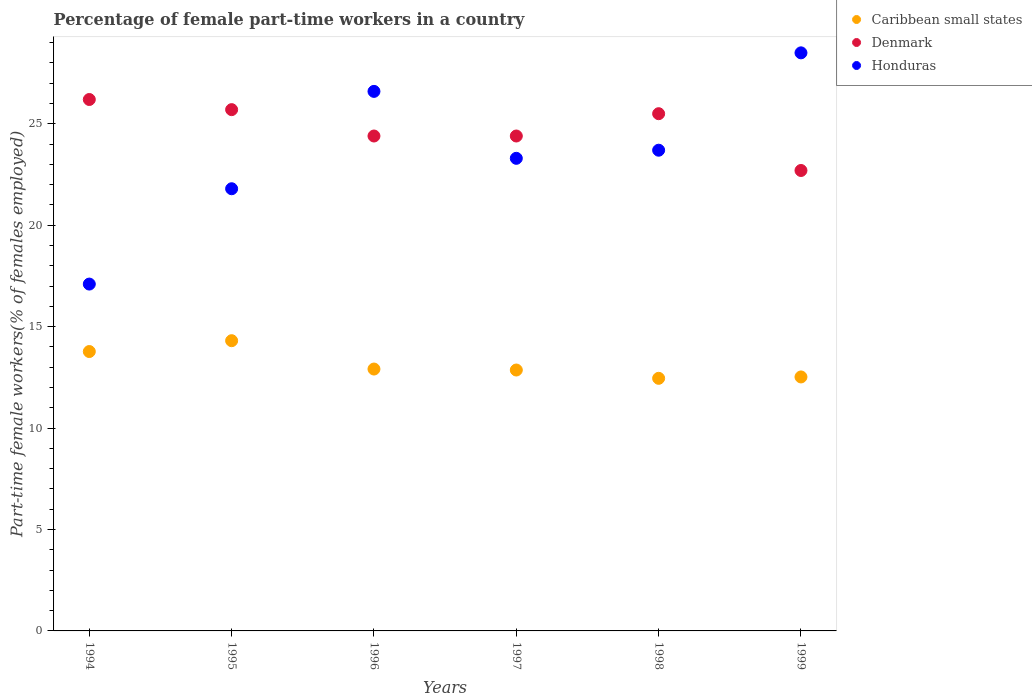Is the number of dotlines equal to the number of legend labels?
Your answer should be compact. Yes. What is the percentage of female part-time workers in Caribbean small states in 1995?
Provide a succinct answer. 14.31. Across all years, what is the maximum percentage of female part-time workers in Denmark?
Ensure brevity in your answer.  26.2. Across all years, what is the minimum percentage of female part-time workers in Caribbean small states?
Your answer should be compact. 12.45. In which year was the percentage of female part-time workers in Honduras maximum?
Your answer should be very brief. 1999. In which year was the percentage of female part-time workers in Honduras minimum?
Your response must be concise. 1994. What is the total percentage of female part-time workers in Denmark in the graph?
Your answer should be very brief. 148.9. What is the difference between the percentage of female part-time workers in Honduras in 1996 and that in 1999?
Provide a short and direct response. -1.9. What is the difference between the percentage of female part-time workers in Denmark in 1997 and the percentage of female part-time workers in Caribbean small states in 1999?
Provide a short and direct response. 11.88. What is the average percentage of female part-time workers in Honduras per year?
Provide a short and direct response. 23.5. In the year 1996, what is the difference between the percentage of female part-time workers in Caribbean small states and percentage of female part-time workers in Denmark?
Provide a succinct answer. -11.49. What is the ratio of the percentage of female part-time workers in Honduras in 1996 to that in 1998?
Keep it short and to the point. 1.12. Is the sum of the percentage of female part-time workers in Honduras in 1995 and 1999 greater than the maximum percentage of female part-time workers in Caribbean small states across all years?
Offer a very short reply. Yes. Is the percentage of female part-time workers in Denmark strictly greater than the percentage of female part-time workers in Honduras over the years?
Offer a very short reply. No. How many dotlines are there?
Your answer should be very brief. 3. How many years are there in the graph?
Offer a very short reply. 6. Are the values on the major ticks of Y-axis written in scientific E-notation?
Provide a short and direct response. No. Does the graph contain grids?
Your answer should be very brief. No. Where does the legend appear in the graph?
Your response must be concise. Top right. How many legend labels are there?
Keep it short and to the point. 3. How are the legend labels stacked?
Make the answer very short. Vertical. What is the title of the graph?
Offer a terse response. Percentage of female part-time workers in a country. What is the label or title of the Y-axis?
Your response must be concise. Part-time female workers(% of females employed). What is the Part-time female workers(% of females employed) of Caribbean small states in 1994?
Provide a succinct answer. 13.77. What is the Part-time female workers(% of females employed) in Denmark in 1994?
Make the answer very short. 26.2. What is the Part-time female workers(% of females employed) in Honduras in 1994?
Make the answer very short. 17.1. What is the Part-time female workers(% of females employed) of Caribbean small states in 1995?
Give a very brief answer. 14.31. What is the Part-time female workers(% of females employed) of Denmark in 1995?
Ensure brevity in your answer.  25.7. What is the Part-time female workers(% of females employed) of Honduras in 1995?
Provide a succinct answer. 21.8. What is the Part-time female workers(% of females employed) in Caribbean small states in 1996?
Offer a very short reply. 12.91. What is the Part-time female workers(% of females employed) in Denmark in 1996?
Your response must be concise. 24.4. What is the Part-time female workers(% of females employed) of Honduras in 1996?
Provide a short and direct response. 26.6. What is the Part-time female workers(% of females employed) in Caribbean small states in 1997?
Your answer should be very brief. 12.86. What is the Part-time female workers(% of females employed) in Denmark in 1997?
Your answer should be compact. 24.4. What is the Part-time female workers(% of females employed) of Honduras in 1997?
Provide a succinct answer. 23.3. What is the Part-time female workers(% of females employed) of Caribbean small states in 1998?
Give a very brief answer. 12.45. What is the Part-time female workers(% of females employed) in Denmark in 1998?
Your answer should be very brief. 25.5. What is the Part-time female workers(% of females employed) of Honduras in 1998?
Give a very brief answer. 23.7. What is the Part-time female workers(% of females employed) of Caribbean small states in 1999?
Keep it short and to the point. 12.52. What is the Part-time female workers(% of females employed) in Denmark in 1999?
Give a very brief answer. 22.7. What is the Part-time female workers(% of females employed) in Honduras in 1999?
Make the answer very short. 28.5. Across all years, what is the maximum Part-time female workers(% of females employed) of Caribbean small states?
Your response must be concise. 14.31. Across all years, what is the maximum Part-time female workers(% of females employed) of Denmark?
Provide a short and direct response. 26.2. Across all years, what is the maximum Part-time female workers(% of females employed) in Honduras?
Your response must be concise. 28.5. Across all years, what is the minimum Part-time female workers(% of females employed) of Caribbean small states?
Keep it short and to the point. 12.45. Across all years, what is the minimum Part-time female workers(% of females employed) in Denmark?
Provide a succinct answer. 22.7. Across all years, what is the minimum Part-time female workers(% of females employed) of Honduras?
Provide a short and direct response. 17.1. What is the total Part-time female workers(% of females employed) in Caribbean small states in the graph?
Keep it short and to the point. 78.83. What is the total Part-time female workers(% of females employed) in Denmark in the graph?
Make the answer very short. 148.9. What is the total Part-time female workers(% of females employed) of Honduras in the graph?
Offer a terse response. 141. What is the difference between the Part-time female workers(% of females employed) in Caribbean small states in 1994 and that in 1995?
Make the answer very short. -0.53. What is the difference between the Part-time female workers(% of females employed) in Denmark in 1994 and that in 1995?
Your response must be concise. 0.5. What is the difference between the Part-time female workers(% of females employed) in Honduras in 1994 and that in 1995?
Keep it short and to the point. -4.7. What is the difference between the Part-time female workers(% of females employed) in Caribbean small states in 1994 and that in 1996?
Your answer should be compact. 0.86. What is the difference between the Part-time female workers(% of females employed) of Denmark in 1994 and that in 1996?
Ensure brevity in your answer.  1.8. What is the difference between the Part-time female workers(% of females employed) in Honduras in 1994 and that in 1996?
Your answer should be very brief. -9.5. What is the difference between the Part-time female workers(% of females employed) of Caribbean small states in 1994 and that in 1997?
Your answer should be compact. 0.91. What is the difference between the Part-time female workers(% of females employed) of Caribbean small states in 1994 and that in 1998?
Make the answer very short. 1.32. What is the difference between the Part-time female workers(% of females employed) in Honduras in 1994 and that in 1998?
Provide a succinct answer. -6.6. What is the difference between the Part-time female workers(% of females employed) of Caribbean small states in 1994 and that in 1999?
Your response must be concise. 1.25. What is the difference between the Part-time female workers(% of females employed) in Caribbean small states in 1995 and that in 1996?
Make the answer very short. 1.4. What is the difference between the Part-time female workers(% of females employed) of Honduras in 1995 and that in 1996?
Provide a succinct answer. -4.8. What is the difference between the Part-time female workers(% of females employed) of Caribbean small states in 1995 and that in 1997?
Offer a very short reply. 1.45. What is the difference between the Part-time female workers(% of females employed) of Caribbean small states in 1995 and that in 1998?
Provide a succinct answer. 1.85. What is the difference between the Part-time female workers(% of females employed) in Honduras in 1995 and that in 1998?
Provide a short and direct response. -1.9. What is the difference between the Part-time female workers(% of females employed) in Caribbean small states in 1995 and that in 1999?
Ensure brevity in your answer.  1.79. What is the difference between the Part-time female workers(% of females employed) in Denmark in 1995 and that in 1999?
Give a very brief answer. 3. What is the difference between the Part-time female workers(% of females employed) of Honduras in 1995 and that in 1999?
Your response must be concise. -6.7. What is the difference between the Part-time female workers(% of females employed) in Caribbean small states in 1996 and that in 1997?
Make the answer very short. 0.05. What is the difference between the Part-time female workers(% of females employed) of Denmark in 1996 and that in 1997?
Ensure brevity in your answer.  0. What is the difference between the Part-time female workers(% of females employed) in Honduras in 1996 and that in 1997?
Keep it short and to the point. 3.3. What is the difference between the Part-time female workers(% of females employed) in Caribbean small states in 1996 and that in 1998?
Your response must be concise. 0.46. What is the difference between the Part-time female workers(% of females employed) in Caribbean small states in 1996 and that in 1999?
Keep it short and to the point. 0.39. What is the difference between the Part-time female workers(% of females employed) of Denmark in 1996 and that in 1999?
Provide a succinct answer. 1.7. What is the difference between the Part-time female workers(% of females employed) of Caribbean small states in 1997 and that in 1998?
Offer a very short reply. 0.41. What is the difference between the Part-time female workers(% of females employed) in Denmark in 1997 and that in 1998?
Give a very brief answer. -1.1. What is the difference between the Part-time female workers(% of females employed) of Honduras in 1997 and that in 1998?
Your response must be concise. -0.4. What is the difference between the Part-time female workers(% of females employed) of Caribbean small states in 1997 and that in 1999?
Your response must be concise. 0.34. What is the difference between the Part-time female workers(% of females employed) in Caribbean small states in 1998 and that in 1999?
Ensure brevity in your answer.  -0.07. What is the difference between the Part-time female workers(% of females employed) in Denmark in 1998 and that in 1999?
Provide a short and direct response. 2.8. What is the difference between the Part-time female workers(% of females employed) in Honduras in 1998 and that in 1999?
Make the answer very short. -4.8. What is the difference between the Part-time female workers(% of females employed) in Caribbean small states in 1994 and the Part-time female workers(% of females employed) in Denmark in 1995?
Ensure brevity in your answer.  -11.93. What is the difference between the Part-time female workers(% of females employed) of Caribbean small states in 1994 and the Part-time female workers(% of females employed) of Honduras in 1995?
Offer a very short reply. -8.03. What is the difference between the Part-time female workers(% of females employed) of Caribbean small states in 1994 and the Part-time female workers(% of females employed) of Denmark in 1996?
Make the answer very short. -10.63. What is the difference between the Part-time female workers(% of females employed) in Caribbean small states in 1994 and the Part-time female workers(% of females employed) in Honduras in 1996?
Provide a succinct answer. -12.83. What is the difference between the Part-time female workers(% of females employed) of Caribbean small states in 1994 and the Part-time female workers(% of females employed) of Denmark in 1997?
Ensure brevity in your answer.  -10.63. What is the difference between the Part-time female workers(% of females employed) in Caribbean small states in 1994 and the Part-time female workers(% of females employed) in Honduras in 1997?
Provide a succinct answer. -9.53. What is the difference between the Part-time female workers(% of females employed) of Denmark in 1994 and the Part-time female workers(% of females employed) of Honduras in 1997?
Your response must be concise. 2.9. What is the difference between the Part-time female workers(% of females employed) of Caribbean small states in 1994 and the Part-time female workers(% of females employed) of Denmark in 1998?
Provide a succinct answer. -11.73. What is the difference between the Part-time female workers(% of females employed) of Caribbean small states in 1994 and the Part-time female workers(% of females employed) of Honduras in 1998?
Your answer should be very brief. -9.93. What is the difference between the Part-time female workers(% of females employed) of Caribbean small states in 1994 and the Part-time female workers(% of females employed) of Denmark in 1999?
Keep it short and to the point. -8.93. What is the difference between the Part-time female workers(% of females employed) of Caribbean small states in 1994 and the Part-time female workers(% of females employed) of Honduras in 1999?
Give a very brief answer. -14.73. What is the difference between the Part-time female workers(% of females employed) of Denmark in 1994 and the Part-time female workers(% of females employed) of Honduras in 1999?
Provide a short and direct response. -2.3. What is the difference between the Part-time female workers(% of females employed) of Caribbean small states in 1995 and the Part-time female workers(% of females employed) of Denmark in 1996?
Your response must be concise. -10.09. What is the difference between the Part-time female workers(% of females employed) of Caribbean small states in 1995 and the Part-time female workers(% of females employed) of Honduras in 1996?
Make the answer very short. -12.29. What is the difference between the Part-time female workers(% of females employed) of Caribbean small states in 1995 and the Part-time female workers(% of females employed) of Denmark in 1997?
Keep it short and to the point. -10.09. What is the difference between the Part-time female workers(% of females employed) of Caribbean small states in 1995 and the Part-time female workers(% of females employed) of Honduras in 1997?
Ensure brevity in your answer.  -8.99. What is the difference between the Part-time female workers(% of females employed) in Denmark in 1995 and the Part-time female workers(% of females employed) in Honduras in 1997?
Keep it short and to the point. 2.4. What is the difference between the Part-time female workers(% of females employed) in Caribbean small states in 1995 and the Part-time female workers(% of females employed) in Denmark in 1998?
Provide a short and direct response. -11.19. What is the difference between the Part-time female workers(% of females employed) of Caribbean small states in 1995 and the Part-time female workers(% of females employed) of Honduras in 1998?
Your answer should be compact. -9.39. What is the difference between the Part-time female workers(% of females employed) of Denmark in 1995 and the Part-time female workers(% of females employed) of Honduras in 1998?
Your answer should be compact. 2. What is the difference between the Part-time female workers(% of females employed) in Caribbean small states in 1995 and the Part-time female workers(% of females employed) in Denmark in 1999?
Make the answer very short. -8.39. What is the difference between the Part-time female workers(% of females employed) in Caribbean small states in 1995 and the Part-time female workers(% of females employed) in Honduras in 1999?
Give a very brief answer. -14.19. What is the difference between the Part-time female workers(% of females employed) of Caribbean small states in 1996 and the Part-time female workers(% of females employed) of Denmark in 1997?
Make the answer very short. -11.49. What is the difference between the Part-time female workers(% of females employed) in Caribbean small states in 1996 and the Part-time female workers(% of females employed) in Honduras in 1997?
Offer a terse response. -10.39. What is the difference between the Part-time female workers(% of females employed) of Caribbean small states in 1996 and the Part-time female workers(% of females employed) of Denmark in 1998?
Offer a terse response. -12.59. What is the difference between the Part-time female workers(% of females employed) of Caribbean small states in 1996 and the Part-time female workers(% of females employed) of Honduras in 1998?
Keep it short and to the point. -10.79. What is the difference between the Part-time female workers(% of females employed) of Caribbean small states in 1996 and the Part-time female workers(% of females employed) of Denmark in 1999?
Your answer should be very brief. -9.79. What is the difference between the Part-time female workers(% of females employed) in Caribbean small states in 1996 and the Part-time female workers(% of females employed) in Honduras in 1999?
Give a very brief answer. -15.59. What is the difference between the Part-time female workers(% of females employed) in Denmark in 1996 and the Part-time female workers(% of females employed) in Honduras in 1999?
Your answer should be very brief. -4.1. What is the difference between the Part-time female workers(% of females employed) in Caribbean small states in 1997 and the Part-time female workers(% of females employed) in Denmark in 1998?
Offer a very short reply. -12.64. What is the difference between the Part-time female workers(% of females employed) of Caribbean small states in 1997 and the Part-time female workers(% of females employed) of Honduras in 1998?
Keep it short and to the point. -10.84. What is the difference between the Part-time female workers(% of females employed) in Denmark in 1997 and the Part-time female workers(% of females employed) in Honduras in 1998?
Offer a very short reply. 0.7. What is the difference between the Part-time female workers(% of females employed) in Caribbean small states in 1997 and the Part-time female workers(% of females employed) in Denmark in 1999?
Make the answer very short. -9.84. What is the difference between the Part-time female workers(% of females employed) in Caribbean small states in 1997 and the Part-time female workers(% of females employed) in Honduras in 1999?
Ensure brevity in your answer.  -15.64. What is the difference between the Part-time female workers(% of females employed) in Caribbean small states in 1998 and the Part-time female workers(% of females employed) in Denmark in 1999?
Ensure brevity in your answer.  -10.25. What is the difference between the Part-time female workers(% of females employed) in Caribbean small states in 1998 and the Part-time female workers(% of females employed) in Honduras in 1999?
Keep it short and to the point. -16.05. What is the average Part-time female workers(% of females employed) in Caribbean small states per year?
Provide a short and direct response. 13.14. What is the average Part-time female workers(% of females employed) in Denmark per year?
Your answer should be compact. 24.82. What is the average Part-time female workers(% of females employed) of Honduras per year?
Your answer should be very brief. 23.5. In the year 1994, what is the difference between the Part-time female workers(% of females employed) in Caribbean small states and Part-time female workers(% of females employed) in Denmark?
Provide a succinct answer. -12.43. In the year 1994, what is the difference between the Part-time female workers(% of females employed) of Caribbean small states and Part-time female workers(% of females employed) of Honduras?
Offer a very short reply. -3.33. In the year 1994, what is the difference between the Part-time female workers(% of females employed) in Denmark and Part-time female workers(% of females employed) in Honduras?
Your answer should be compact. 9.1. In the year 1995, what is the difference between the Part-time female workers(% of females employed) in Caribbean small states and Part-time female workers(% of females employed) in Denmark?
Offer a very short reply. -11.39. In the year 1995, what is the difference between the Part-time female workers(% of females employed) of Caribbean small states and Part-time female workers(% of females employed) of Honduras?
Provide a short and direct response. -7.49. In the year 1996, what is the difference between the Part-time female workers(% of females employed) of Caribbean small states and Part-time female workers(% of females employed) of Denmark?
Provide a short and direct response. -11.49. In the year 1996, what is the difference between the Part-time female workers(% of females employed) of Caribbean small states and Part-time female workers(% of females employed) of Honduras?
Give a very brief answer. -13.69. In the year 1997, what is the difference between the Part-time female workers(% of females employed) in Caribbean small states and Part-time female workers(% of females employed) in Denmark?
Offer a terse response. -11.54. In the year 1997, what is the difference between the Part-time female workers(% of females employed) of Caribbean small states and Part-time female workers(% of females employed) of Honduras?
Your answer should be very brief. -10.44. In the year 1998, what is the difference between the Part-time female workers(% of females employed) of Caribbean small states and Part-time female workers(% of females employed) of Denmark?
Keep it short and to the point. -13.05. In the year 1998, what is the difference between the Part-time female workers(% of females employed) in Caribbean small states and Part-time female workers(% of females employed) in Honduras?
Your response must be concise. -11.25. In the year 1999, what is the difference between the Part-time female workers(% of females employed) of Caribbean small states and Part-time female workers(% of females employed) of Denmark?
Offer a very short reply. -10.18. In the year 1999, what is the difference between the Part-time female workers(% of females employed) of Caribbean small states and Part-time female workers(% of females employed) of Honduras?
Offer a very short reply. -15.98. What is the ratio of the Part-time female workers(% of females employed) in Caribbean small states in 1994 to that in 1995?
Provide a short and direct response. 0.96. What is the ratio of the Part-time female workers(% of females employed) of Denmark in 1994 to that in 1995?
Your answer should be very brief. 1.02. What is the ratio of the Part-time female workers(% of females employed) in Honduras in 1994 to that in 1995?
Provide a succinct answer. 0.78. What is the ratio of the Part-time female workers(% of females employed) of Caribbean small states in 1994 to that in 1996?
Offer a terse response. 1.07. What is the ratio of the Part-time female workers(% of females employed) of Denmark in 1994 to that in 1996?
Give a very brief answer. 1.07. What is the ratio of the Part-time female workers(% of females employed) in Honduras in 1994 to that in 1996?
Keep it short and to the point. 0.64. What is the ratio of the Part-time female workers(% of females employed) in Caribbean small states in 1994 to that in 1997?
Keep it short and to the point. 1.07. What is the ratio of the Part-time female workers(% of females employed) in Denmark in 1994 to that in 1997?
Your response must be concise. 1.07. What is the ratio of the Part-time female workers(% of females employed) in Honduras in 1994 to that in 1997?
Offer a terse response. 0.73. What is the ratio of the Part-time female workers(% of females employed) of Caribbean small states in 1994 to that in 1998?
Provide a succinct answer. 1.11. What is the ratio of the Part-time female workers(% of females employed) in Denmark in 1994 to that in 1998?
Provide a succinct answer. 1.03. What is the ratio of the Part-time female workers(% of females employed) in Honduras in 1994 to that in 1998?
Keep it short and to the point. 0.72. What is the ratio of the Part-time female workers(% of females employed) of Caribbean small states in 1994 to that in 1999?
Make the answer very short. 1.1. What is the ratio of the Part-time female workers(% of females employed) in Denmark in 1994 to that in 1999?
Give a very brief answer. 1.15. What is the ratio of the Part-time female workers(% of females employed) in Honduras in 1994 to that in 1999?
Your response must be concise. 0.6. What is the ratio of the Part-time female workers(% of females employed) of Caribbean small states in 1995 to that in 1996?
Give a very brief answer. 1.11. What is the ratio of the Part-time female workers(% of females employed) in Denmark in 1995 to that in 1996?
Your answer should be very brief. 1.05. What is the ratio of the Part-time female workers(% of females employed) in Honduras in 1995 to that in 1996?
Ensure brevity in your answer.  0.82. What is the ratio of the Part-time female workers(% of females employed) in Caribbean small states in 1995 to that in 1997?
Provide a short and direct response. 1.11. What is the ratio of the Part-time female workers(% of females employed) of Denmark in 1995 to that in 1997?
Provide a short and direct response. 1.05. What is the ratio of the Part-time female workers(% of females employed) in Honduras in 1995 to that in 1997?
Your response must be concise. 0.94. What is the ratio of the Part-time female workers(% of females employed) in Caribbean small states in 1995 to that in 1998?
Your answer should be compact. 1.15. What is the ratio of the Part-time female workers(% of females employed) in Denmark in 1995 to that in 1998?
Make the answer very short. 1.01. What is the ratio of the Part-time female workers(% of females employed) in Honduras in 1995 to that in 1998?
Make the answer very short. 0.92. What is the ratio of the Part-time female workers(% of females employed) in Caribbean small states in 1995 to that in 1999?
Offer a terse response. 1.14. What is the ratio of the Part-time female workers(% of females employed) in Denmark in 1995 to that in 1999?
Give a very brief answer. 1.13. What is the ratio of the Part-time female workers(% of females employed) in Honduras in 1995 to that in 1999?
Give a very brief answer. 0.76. What is the ratio of the Part-time female workers(% of females employed) of Honduras in 1996 to that in 1997?
Offer a terse response. 1.14. What is the ratio of the Part-time female workers(% of females employed) of Caribbean small states in 1996 to that in 1998?
Your answer should be compact. 1.04. What is the ratio of the Part-time female workers(% of females employed) of Denmark in 1996 to that in 1998?
Provide a succinct answer. 0.96. What is the ratio of the Part-time female workers(% of females employed) in Honduras in 1996 to that in 1998?
Your answer should be compact. 1.12. What is the ratio of the Part-time female workers(% of females employed) of Caribbean small states in 1996 to that in 1999?
Give a very brief answer. 1.03. What is the ratio of the Part-time female workers(% of females employed) in Denmark in 1996 to that in 1999?
Keep it short and to the point. 1.07. What is the ratio of the Part-time female workers(% of females employed) of Caribbean small states in 1997 to that in 1998?
Provide a succinct answer. 1.03. What is the ratio of the Part-time female workers(% of females employed) of Denmark in 1997 to that in 1998?
Make the answer very short. 0.96. What is the ratio of the Part-time female workers(% of females employed) in Honduras in 1997 to that in 1998?
Give a very brief answer. 0.98. What is the ratio of the Part-time female workers(% of females employed) in Caribbean small states in 1997 to that in 1999?
Ensure brevity in your answer.  1.03. What is the ratio of the Part-time female workers(% of females employed) of Denmark in 1997 to that in 1999?
Give a very brief answer. 1.07. What is the ratio of the Part-time female workers(% of females employed) in Honduras in 1997 to that in 1999?
Ensure brevity in your answer.  0.82. What is the ratio of the Part-time female workers(% of females employed) of Denmark in 1998 to that in 1999?
Provide a short and direct response. 1.12. What is the ratio of the Part-time female workers(% of females employed) of Honduras in 1998 to that in 1999?
Offer a terse response. 0.83. What is the difference between the highest and the second highest Part-time female workers(% of females employed) of Caribbean small states?
Your answer should be compact. 0.53. What is the difference between the highest and the second highest Part-time female workers(% of females employed) of Denmark?
Ensure brevity in your answer.  0.5. What is the difference between the highest and the second highest Part-time female workers(% of females employed) of Honduras?
Your answer should be very brief. 1.9. What is the difference between the highest and the lowest Part-time female workers(% of females employed) of Caribbean small states?
Provide a short and direct response. 1.85. What is the difference between the highest and the lowest Part-time female workers(% of females employed) in Denmark?
Make the answer very short. 3.5. What is the difference between the highest and the lowest Part-time female workers(% of females employed) in Honduras?
Ensure brevity in your answer.  11.4. 